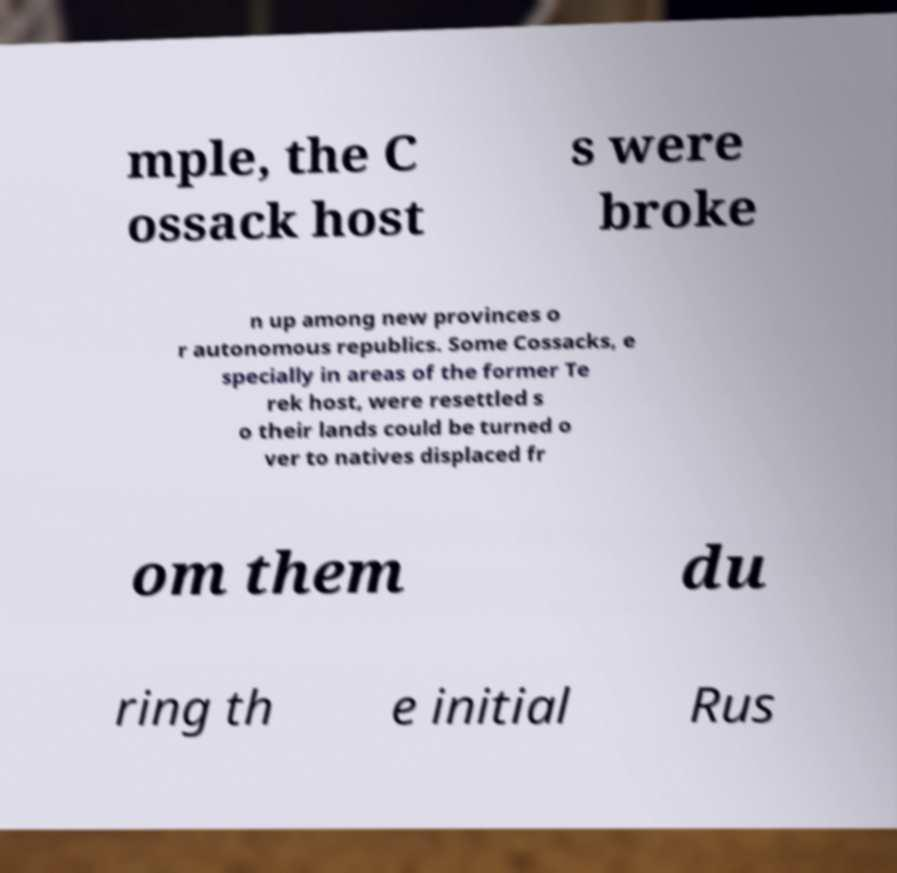What messages or text are displayed in this image? I need them in a readable, typed format. mple, the C ossack host s were broke n up among new provinces o r autonomous republics. Some Cossacks, e specially in areas of the former Te rek host, were resettled s o their lands could be turned o ver to natives displaced fr om them du ring th e initial Rus 